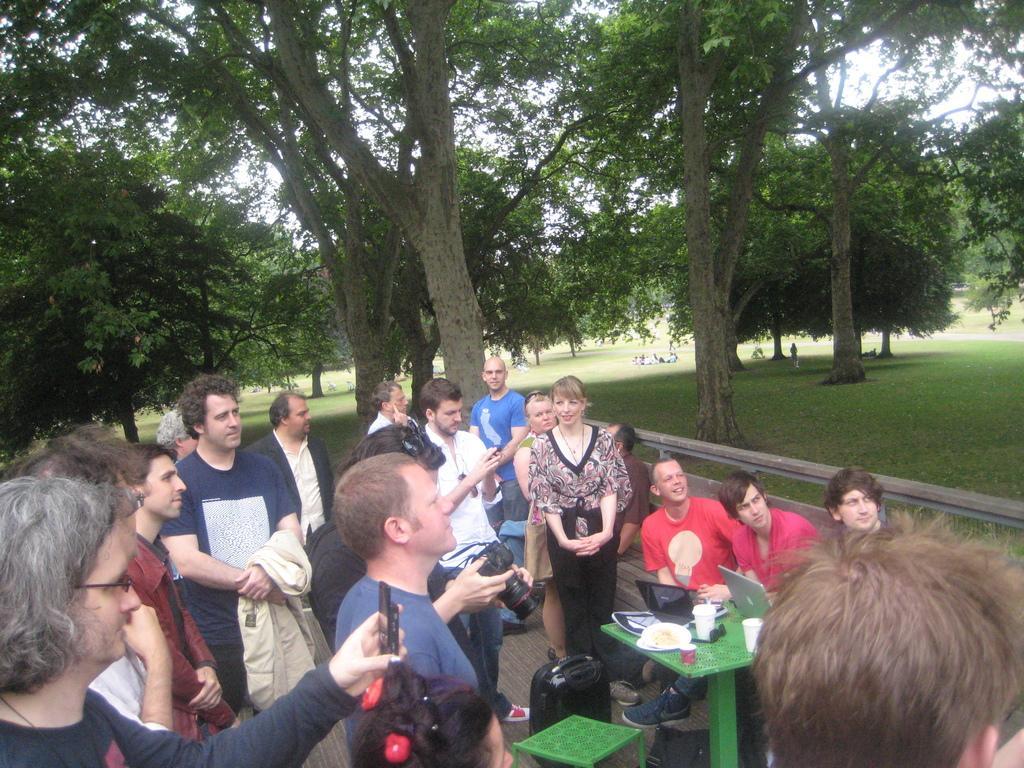In one or two sentences, can you explain what this image depicts? In this image I can see number of persons standing and few of them are holding cameras in their hands. I can see few persons sitting in front of a green colored table and on the table I can see few laptops, few cups and few other objects. In the background I can see few trees, some grass, few persons and the sky. 